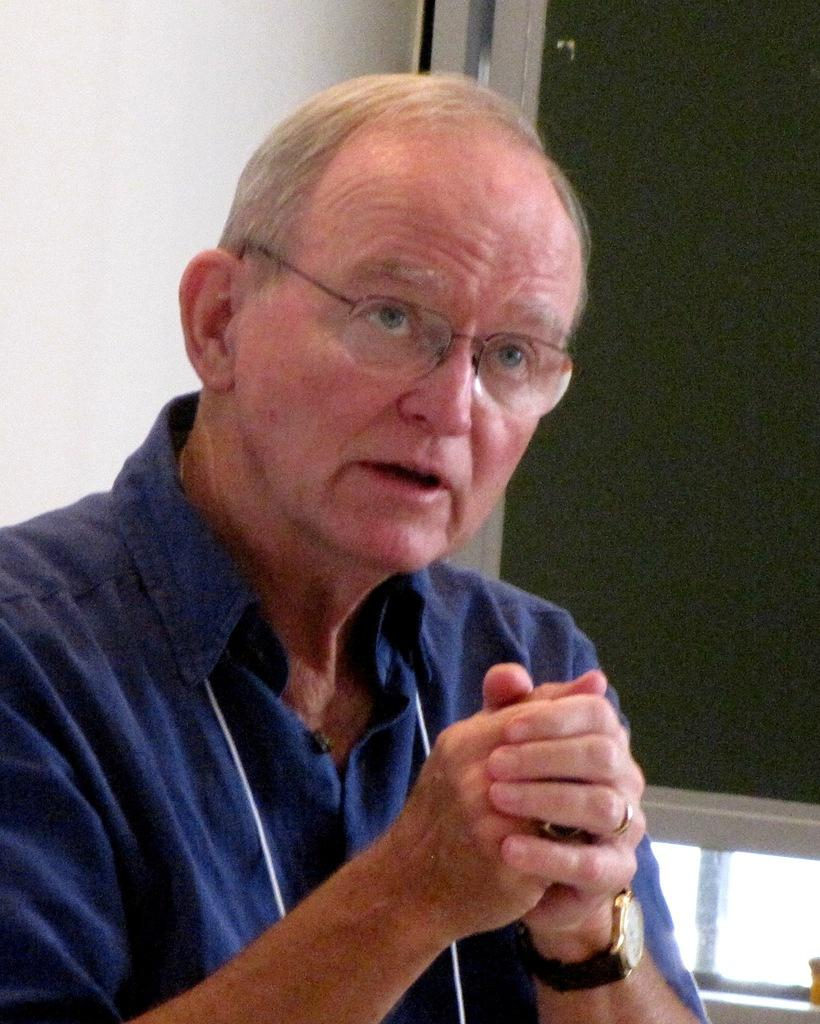Who is present in the image? There is a man in the image. What is the man wearing? The man is wearing a blue dress, a watch, and glasses (specs). What color is the board in the background of the image? There is a green color board in the background of the image. Can you see any cream on the island in the image? There is no island or cream present in the image. What type of plane is flying over the man in the image? There is no plane visible in the image. 